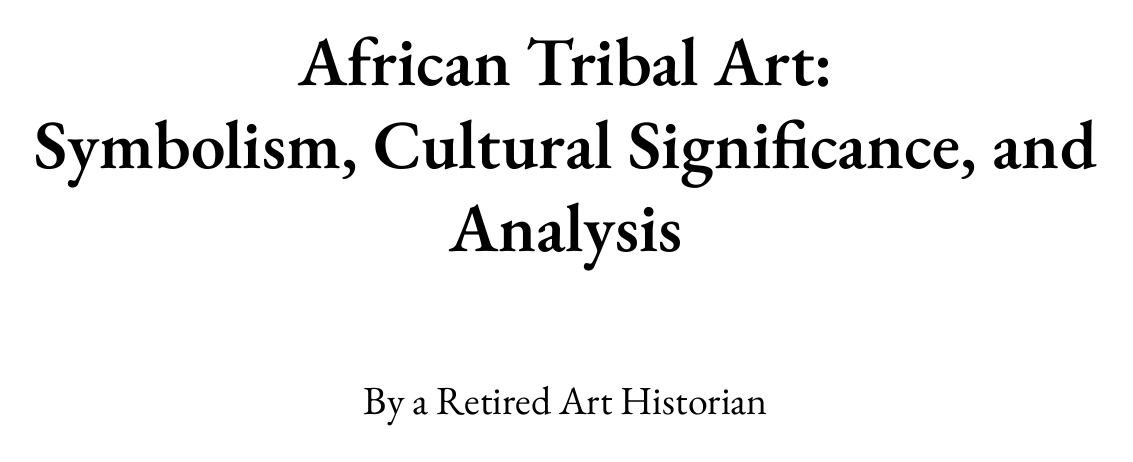What are the major art-producing cultures discussed? The document outlines major art-producing cultures including Yoruba, Dogon, Benin, and Kongo.
Answer: Yoruba, Dogon, Benin, Kongo What significance is attributed to masks in African art? Masks play a vital role in rituals and ceremonies as detailed in the cultural significance chapter.
Answer: Rituals and ceremonies What does the chapter on symbolism examine? The chapter on symbolism examines common symbols and their meanings, along with color symbolism.
Answer: Common symbols and their meanings How many case studies are presented in the document? The case studies chapter lists four significant analyses: Benin Bronzes, Yoruba Gelede masks, Kongo Nkisi figures, and Dogon cliff dwellings.
Answer: Four What is emphasized regarding the importance of oral traditions? The oral traditions are highlighted in the context of interpreting African art, showing their vital role.
Answer: Vital role Which section discusses ethical considerations in studying African art? Ethical considerations are specifically addressed in the research methodologies section of the document.
Answer: Research Methodologies in African Art History What does the appendix include that helps with terminology? The appendix features a glossary that provides a comprehensive list of terms related to African tribal art.
Answer: Glossary of African Art Terms What are two contemporary issues highlighted in the document? The document raises issues like the impact of colonialism and the global market's influence on African art.
Answer: Colonialism, global market What methodology is mentioned for analyzing African tribal art? Several methodologies are noted, including formal analysis, contextual analysis, comparative analysis, and technological analysis.
Answer: Formal analysis, contextual analysis, comparative analysis, technological analysis 